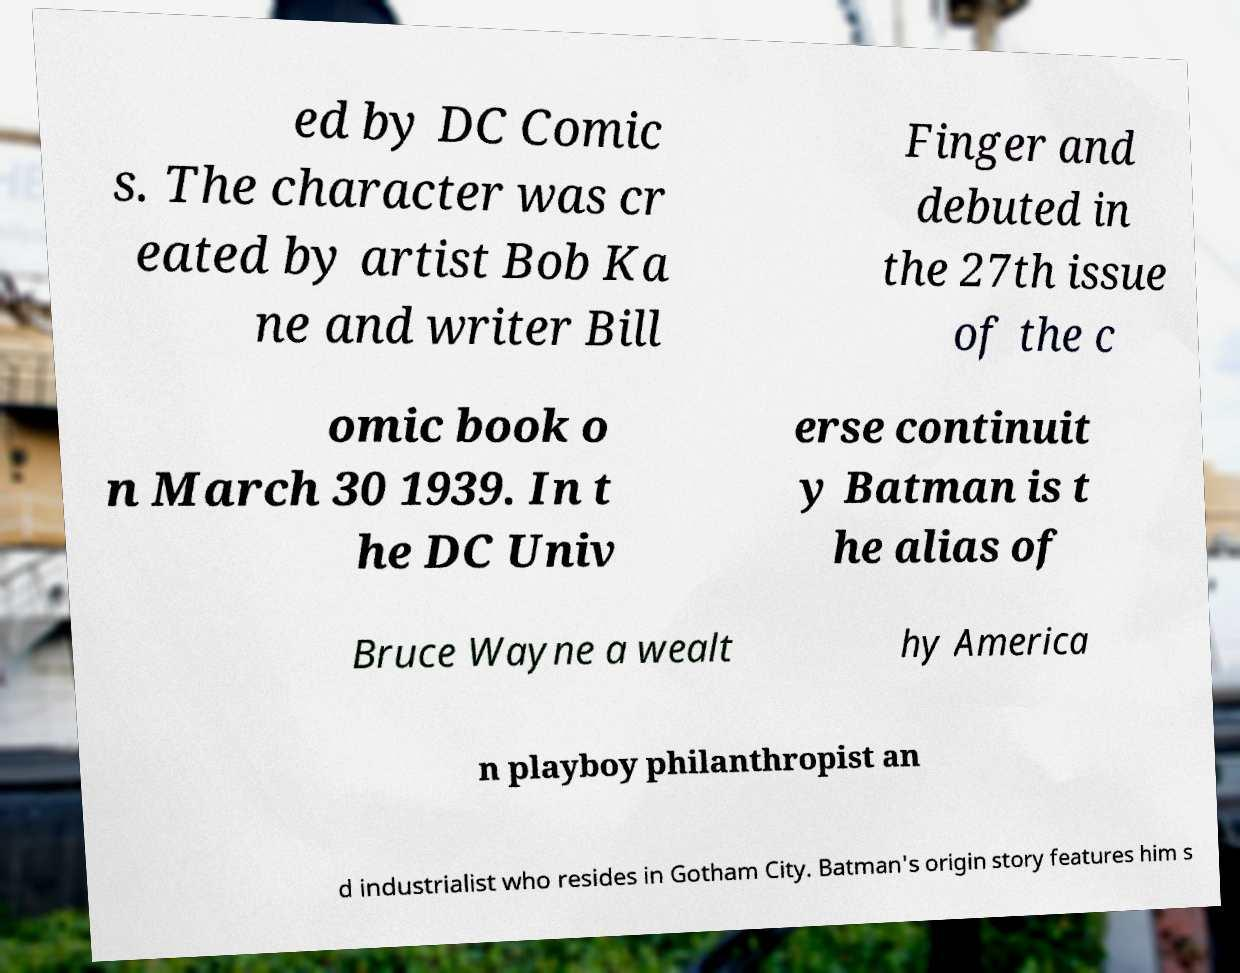Please identify and transcribe the text found in this image. ed by DC Comic s. The character was cr eated by artist Bob Ka ne and writer Bill Finger and debuted in the 27th issue of the c omic book o n March 30 1939. In t he DC Univ erse continuit y Batman is t he alias of Bruce Wayne a wealt hy America n playboy philanthropist an d industrialist who resides in Gotham City. Batman's origin story features him s 